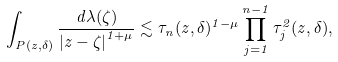Convert formula to latex. <formula><loc_0><loc_0><loc_500><loc_500>\int _ { P ( z , \delta ) } \frac { d \lambda ( \zeta ) } { \left | z - \zeta \right | ^ { 1 + \mu } } \lesssim \tau _ { n } ( z , \delta ) ^ { 1 - \mu } \prod _ { j = 1 } ^ { n - 1 } \tau _ { j } ^ { 2 } ( z , \delta ) ,</formula> 